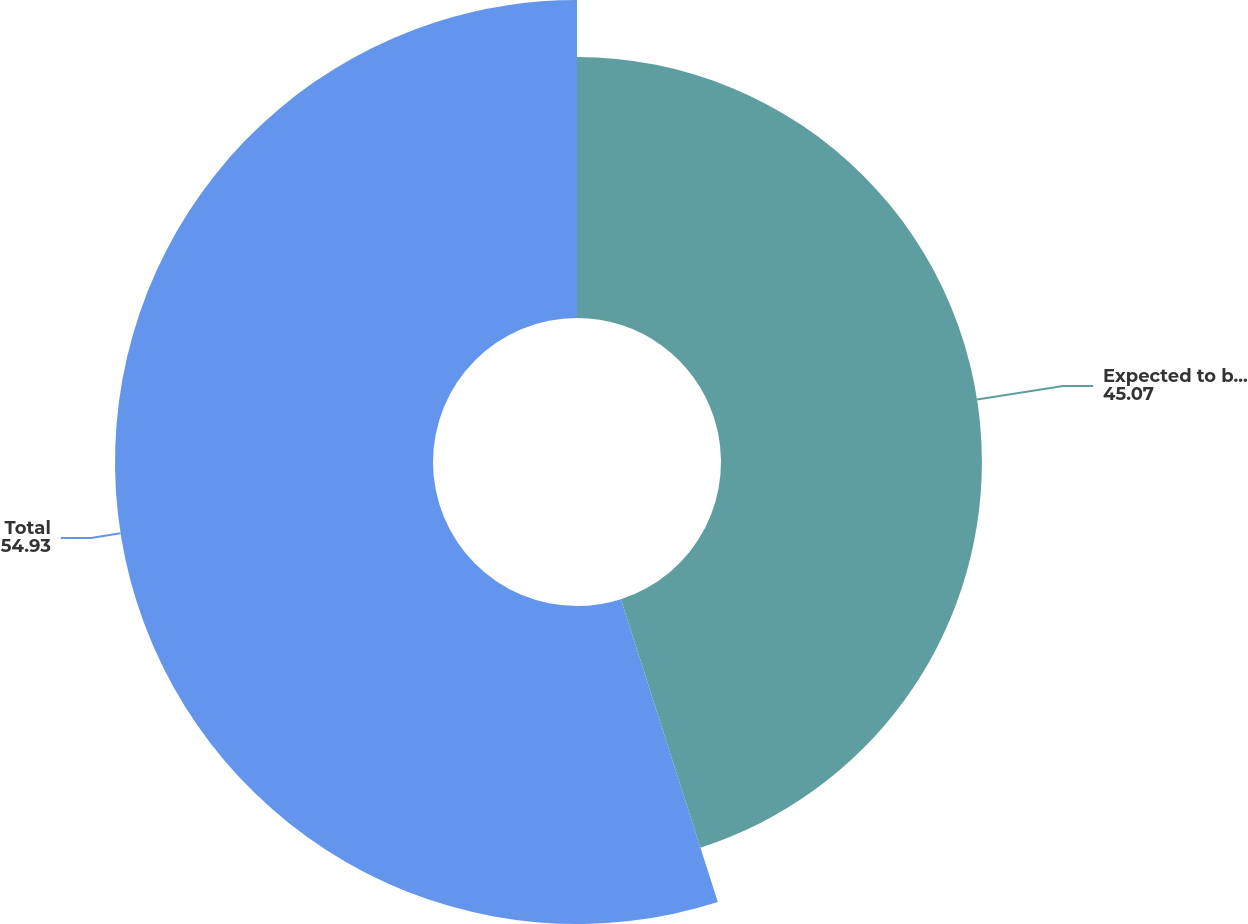Convert chart. <chart><loc_0><loc_0><loc_500><loc_500><pie_chart><fcel>Expected to be collected after<fcel>Total<nl><fcel>45.07%<fcel>54.93%<nl></chart> 